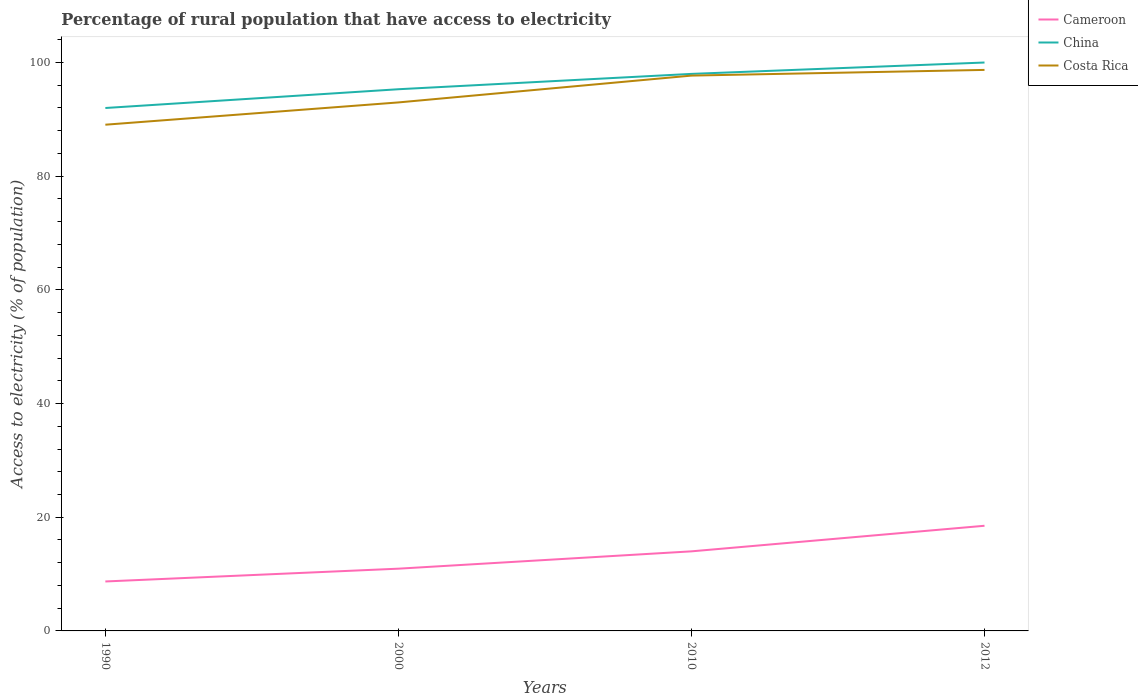How many different coloured lines are there?
Make the answer very short. 3. Is the number of lines equal to the number of legend labels?
Your answer should be very brief. Yes. Across all years, what is the maximum percentage of rural population that have access to electricity in China?
Your answer should be compact. 92. In which year was the percentage of rural population that have access to electricity in Cameroon maximum?
Give a very brief answer. 1990. What is the total percentage of rural population that have access to electricity in China in the graph?
Your answer should be compact. -2. What is the difference between the highest and the lowest percentage of rural population that have access to electricity in China?
Keep it short and to the point. 2. Is the percentage of rural population that have access to electricity in Cameroon strictly greater than the percentage of rural population that have access to electricity in China over the years?
Make the answer very short. Yes. How many lines are there?
Ensure brevity in your answer.  3. How many years are there in the graph?
Offer a very short reply. 4. How are the legend labels stacked?
Your answer should be compact. Vertical. What is the title of the graph?
Keep it short and to the point. Percentage of rural population that have access to electricity. What is the label or title of the Y-axis?
Ensure brevity in your answer.  Access to electricity (% of population). What is the Access to electricity (% of population) of China in 1990?
Offer a very short reply. 92. What is the Access to electricity (% of population) in Costa Rica in 1990?
Your answer should be compact. 89.06. What is the Access to electricity (% of population) of Cameroon in 2000?
Keep it short and to the point. 10.95. What is the Access to electricity (% of population) in China in 2000?
Keep it short and to the point. 95.3. What is the Access to electricity (% of population) in Costa Rica in 2000?
Provide a succinct answer. 92.98. What is the Access to electricity (% of population) of China in 2010?
Offer a very short reply. 98. What is the Access to electricity (% of population) of Costa Rica in 2010?
Provide a short and direct response. 97.7. What is the Access to electricity (% of population) of China in 2012?
Make the answer very short. 100. What is the Access to electricity (% of population) of Costa Rica in 2012?
Give a very brief answer. 98.7. Across all years, what is the maximum Access to electricity (% of population) in Cameroon?
Keep it short and to the point. 18.5. Across all years, what is the maximum Access to electricity (% of population) in China?
Offer a very short reply. 100. Across all years, what is the maximum Access to electricity (% of population) of Costa Rica?
Ensure brevity in your answer.  98.7. Across all years, what is the minimum Access to electricity (% of population) of Cameroon?
Ensure brevity in your answer.  8.7. Across all years, what is the minimum Access to electricity (% of population) of China?
Your answer should be compact. 92. Across all years, what is the minimum Access to electricity (% of population) in Costa Rica?
Your answer should be very brief. 89.06. What is the total Access to electricity (% of population) of Cameroon in the graph?
Provide a succinct answer. 52.15. What is the total Access to electricity (% of population) of China in the graph?
Provide a succinct answer. 385.3. What is the total Access to electricity (% of population) in Costa Rica in the graph?
Provide a succinct answer. 378.44. What is the difference between the Access to electricity (% of population) of Cameroon in 1990 and that in 2000?
Your response must be concise. -2.25. What is the difference between the Access to electricity (% of population) of China in 1990 and that in 2000?
Your response must be concise. -3.3. What is the difference between the Access to electricity (% of population) in Costa Rica in 1990 and that in 2000?
Your answer should be compact. -3.92. What is the difference between the Access to electricity (% of population) in Cameroon in 1990 and that in 2010?
Your answer should be compact. -5.3. What is the difference between the Access to electricity (% of population) in Costa Rica in 1990 and that in 2010?
Keep it short and to the point. -8.64. What is the difference between the Access to electricity (% of population) in Costa Rica in 1990 and that in 2012?
Provide a short and direct response. -9.64. What is the difference between the Access to electricity (% of population) of Cameroon in 2000 and that in 2010?
Offer a very short reply. -3.05. What is the difference between the Access to electricity (% of population) in China in 2000 and that in 2010?
Your answer should be compact. -2.7. What is the difference between the Access to electricity (% of population) of Costa Rica in 2000 and that in 2010?
Keep it short and to the point. -4.72. What is the difference between the Access to electricity (% of population) in Cameroon in 2000 and that in 2012?
Offer a terse response. -7.55. What is the difference between the Access to electricity (% of population) of Costa Rica in 2000 and that in 2012?
Offer a terse response. -5.72. What is the difference between the Access to electricity (% of population) in Cameroon in 2010 and that in 2012?
Give a very brief answer. -4.5. What is the difference between the Access to electricity (% of population) in Cameroon in 1990 and the Access to electricity (% of population) in China in 2000?
Your answer should be compact. -86.6. What is the difference between the Access to electricity (% of population) in Cameroon in 1990 and the Access to electricity (% of population) in Costa Rica in 2000?
Give a very brief answer. -84.28. What is the difference between the Access to electricity (% of population) of China in 1990 and the Access to electricity (% of population) of Costa Rica in 2000?
Provide a succinct answer. -0.98. What is the difference between the Access to electricity (% of population) in Cameroon in 1990 and the Access to electricity (% of population) in China in 2010?
Ensure brevity in your answer.  -89.3. What is the difference between the Access to electricity (% of population) in Cameroon in 1990 and the Access to electricity (% of population) in Costa Rica in 2010?
Provide a succinct answer. -89. What is the difference between the Access to electricity (% of population) of Cameroon in 1990 and the Access to electricity (% of population) of China in 2012?
Your answer should be very brief. -91.3. What is the difference between the Access to electricity (% of population) in Cameroon in 1990 and the Access to electricity (% of population) in Costa Rica in 2012?
Provide a short and direct response. -90. What is the difference between the Access to electricity (% of population) in Cameroon in 2000 and the Access to electricity (% of population) in China in 2010?
Offer a terse response. -87.05. What is the difference between the Access to electricity (% of population) in Cameroon in 2000 and the Access to electricity (% of population) in Costa Rica in 2010?
Keep it short and to the point. -86.75. What is the difference between the Access to electricity (% of population) in Cameroon in 2000 and the Access to electricity (% of population) in China in 2012?
Provide a succinct answer. -89.05. What is the difference between the Access to electricity (% of population) of Cameroon in 2000 and the Access to electricity (% of population) of Costa Rica in 2012?
Offer a terse response. -87.75. What is the difference between the Access to electricity (% of population) of China in 2000 and the Access to electricity (% of population) of Costa Rica in 2012?
Ensure brevity in your answer.  -3.4. What is the difference between the Access to electricity (% of population) of Cameroon in 2010 and the Access to electricity (% of population) of China in 2012?
Offer a terse response. -86. What is the difference between the Access to electricity (% of population) in Cameroon in 2010 and the Access to electricity (% of population) in Costa Rica in 2012?
Offer a very short reply. -84.7. What is the average Access to electricity (% of population) in Cameroon per year?
Your response must be concise. 13.04. What is the average Access to electricity (% of population) of China per year?
Offer a very short reply. 96.33. What is the average Access to electricity (% of population) of Costa Rica per year?
Make the answer very short. 94.61. In the year 1990, what is the difference between the Access to electricity (% of population) in Cameroon and Access to electricity (% of population) in China?
Make the answer very short. -83.3. In the year 1990, what is the difference between the Access to electricity (% of population) in Cameroon and Access to electricity (% of population) in Costa Rica?
Your response must be concise. -80.36. In the year 1990, what is the difference between the Access to electricity (% of population) of China and Access to electricity (% of population) of Costa Rica?
Ensure brevity in your answer.  2.94. In the year 2000, what is the difference between the Access to electricity (% of population) in Cameroon and Access to electricity (% of population) in China?
Provide a short and direct response. -84.35. In the year 2000, what is the difference between the Access to electricity (% of population) of Cameroon and Access to electricity (% of population) of Costa Rica?
Give a very brief answer. -82.03. In the year 2000, what is the difference between the Access to electricity (% of population) of China and Access to electricity (% of population) of Costa Rica?
Ensure brevity in your answer.  2.32. In the year 2010, what is the difference between the Access to electricity (% of population) in Cameroon and Access to electricity (% of population) in China?
Provide a short and direct response. -84. In the year 2010, what is the difference between the Access to electricity (% of population) in Cameroon and Access to electricity (% of population) in Costa Rica?
Your answer should be very brief. -83.7. In the year 2010, what is the difference between the Access to electricity (% of population) in China and Access to electricity (% of population) in Costa Rica?
Offer a very short reply. 0.3. In the year 2012, what is the difference between the Access to electricity (% of population) of Cameroon and Access to electricity (% of population) of China?
Offer a very short reply. -81.5. In the year 2012, what is the difference between the Access to electricity (% of population) of Cameroon and Access to electricity (% of population) of Costa Rica?
Offer a terse response. -80.2. What is the ratio of the Access to electricity (% of population) in Cameroon in 1990 to that in 2000?
Your response must be concise. 0.79. What is the ratio of the Access to electricity (% of population) in China in 1990 to that in 2000?
Your answer should be compact. 0.97. What is the ratio of the Access to electricity (% of population) of Costa Rica in 1990 to that in 2000?
Make the answer very short. 0.96. What is the ratio of the Access to electricity (% of population) of Cameroon in 1990 to that in 2010?
Your answer should be compact. 0.62. What is the ratio of the Access to electricity (% of population) in China in 1990 to that in 2010?
Offer a very short reply. 0.94. What is the ratio of the Access to electricity (% of population) of Costa Rica in 1990 to that in 2010?
Make the answer very short. 0.91. What is the ratio of the Access to electricity (% of population) of Cameroon in 1990 to that in 2012?
Your answer should be compact. 0.47. What is the ratio of the Access to electricity (% of population) in China in 1990 to that in 2012?
Offer a very short reply. 0.92. What is the ratio of the Access to electricity (% of population) of Costa Rica in 1990 to that in 2012?
Ensure brevity in your answer.  0.9. What is the ratio of the Access to electricity (% of population) in Cameroon in 2000 to that in 2010?
Provide a succinct answer. 0.78. What is the ratio of the Access to electricity (% of population) in China in 2000 to that in 2010?
Your answer should be very brief. 0.97. What is the ratio of the Access to electricity (% of population) in Costa Rica in 2000 to that in 2010?
Keep it short and to the point. 0.95. What is the ratio of the Access to electricity (% of population) in Cameroon in 2000 to that in 2012?
Your answer should be very brief. 0.59. What is the ratio of the Access to electricity (% of population) of China in 2000 to that in 2012?
Offer a very short reply. 0.95. What is the ratio of the Access to electricity (% of population) of Costa Rica in 2000 to that in 2012?
Offer a very short reply. 0.94. What is the ratio of the Access to electricity (% of population) of Cameroon in 2010 to that in 2012?
Your response must be concise. 0.76. What is the ratio of the Access to electricity (% of population) of China in 2010 to that in 2012?
Ensure brevity in your answer.  0.98. What is the ratio of the Access to electricity (% of population) in Costa Rica in 2010 to that in 2012?
Provide a succinct answer. 0.99. What is the difference between the highest and the second highest Access to electricity (% of population) of Cameroon?
Your response must be concise. 4.5. What is the difference between the highest and the second highest Access to electricity (% of population) of China?
Offer a very short reply. 2. What is the difference between the highest and the second highest Access to electricity (% of population) of Costa Rica?
Your answer should be compact. 1. What is the difference between the highest and the lowest Access to electricity (% of population) of Cameroon?
Provide a short and direct response. 9.8. What is the difference between the highest and the lowest Access to electricity (% of population) of China?
Provide a succinct answer. 8. What is the difference between the highest and the lowest Access to electricity (% of population) in Costa Rica?
Give a very brief answer. 9.64. 